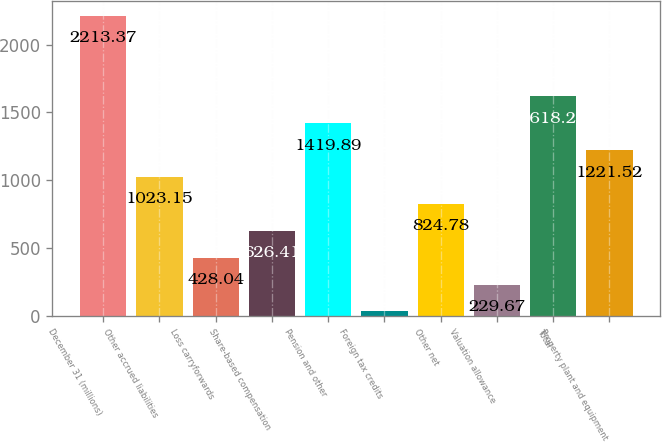Convert chart to OTSL. <chart><loc_0><loc_0><loc_500><loc_500><bar_chart><fcel>December 31 (millions)<fcel>Other accrued liabilities<fcel>Loss carryforwards<fcel>Share-based compensation<fcel>Pension and other<fcel>Foreign tax credits<fcel>Other net<fcel>Valuation allowance<fcel>Total<fcel>Property plant and equipment<nl><fcel>2213.37<fcel>1023.15<fcel>428.04<fcel>626.41<fcel>1419.89<fcel>31.3<fcel>824.78<fcel>229.67<fcel>1618.26<fcel>1221.52<nl></chart> 